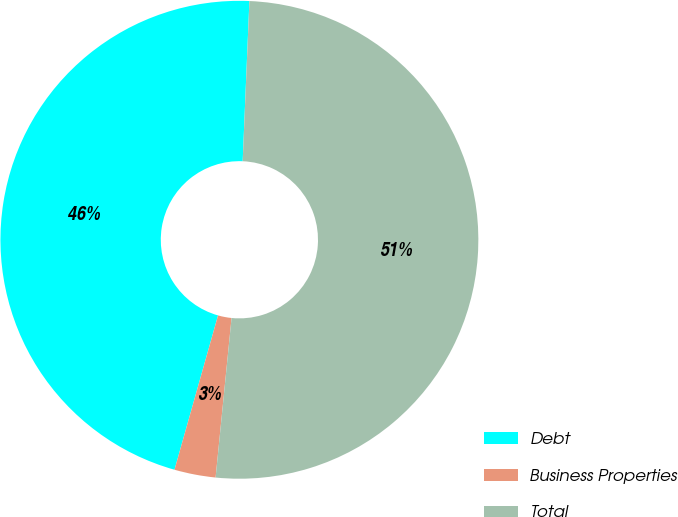Convert chart to OTSL. <chart><loc_0><loc_0><loc_500><loc_500><pie_chart><fcel>Debt<fcel>Business Properties<fcel>Total<nl><fcel>46.29%<fcel>2.79%<fcel>50.92%<nl></chart> 